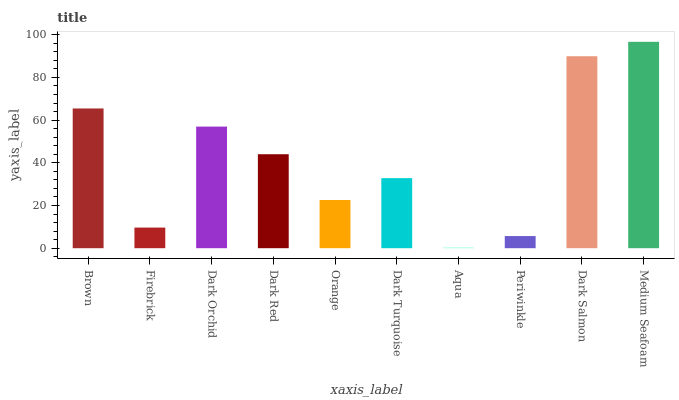Is Aqua the minimum?
Answer yes or no. Yes. Is Medium Seafoam the maximum?
Answer yes or no. Yes. Is Firebrick the minimum?
Answer yes or no. No. Is Firebrick the maximum?
Answer yes or no. No. Is Brown greater than Firebrick?
Answer yes or no. Yes. Is Firebrick less than Brown?
Answer yes or no. Yes. Is Firebrick greater than Brown?
Answer yes or no. No. Is Brown less than Firebrick?
Answer yes or no. No. Is Dark Red the high median?
Answer yes or no. Yes. Is Dark Turquoise the low median?
Answer yes or no. Yes. Is Dark Salmon the high median?
Answer yes or no. No. Is Brown the low median?
Answer yes or no. No. 